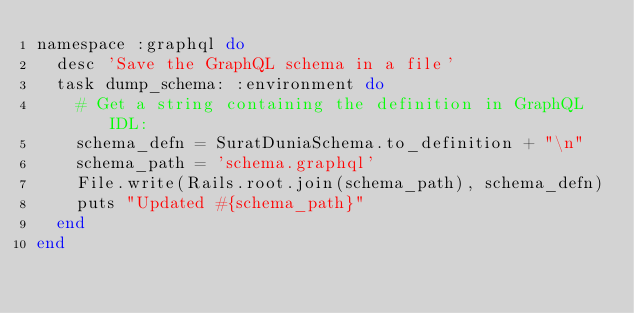Convert code to text. <code><loc_0><loc_0><loc_500><loc_500><_Ruby_>namespace :graphql do
  desc 'Save the GraphQL schema in a file'
  task dump_schema: :environment do
    # Get a string containing the definition in GraphQL IDL:
    schema_defn = SuratDuniaSchema.to_definition + "\n"
    schema_path = 'schema.graphql'
    File.write(Rails.root.join(schema_path), schema_defn)
    puts "Updated #{schema_path}"
  end
end
</code> 